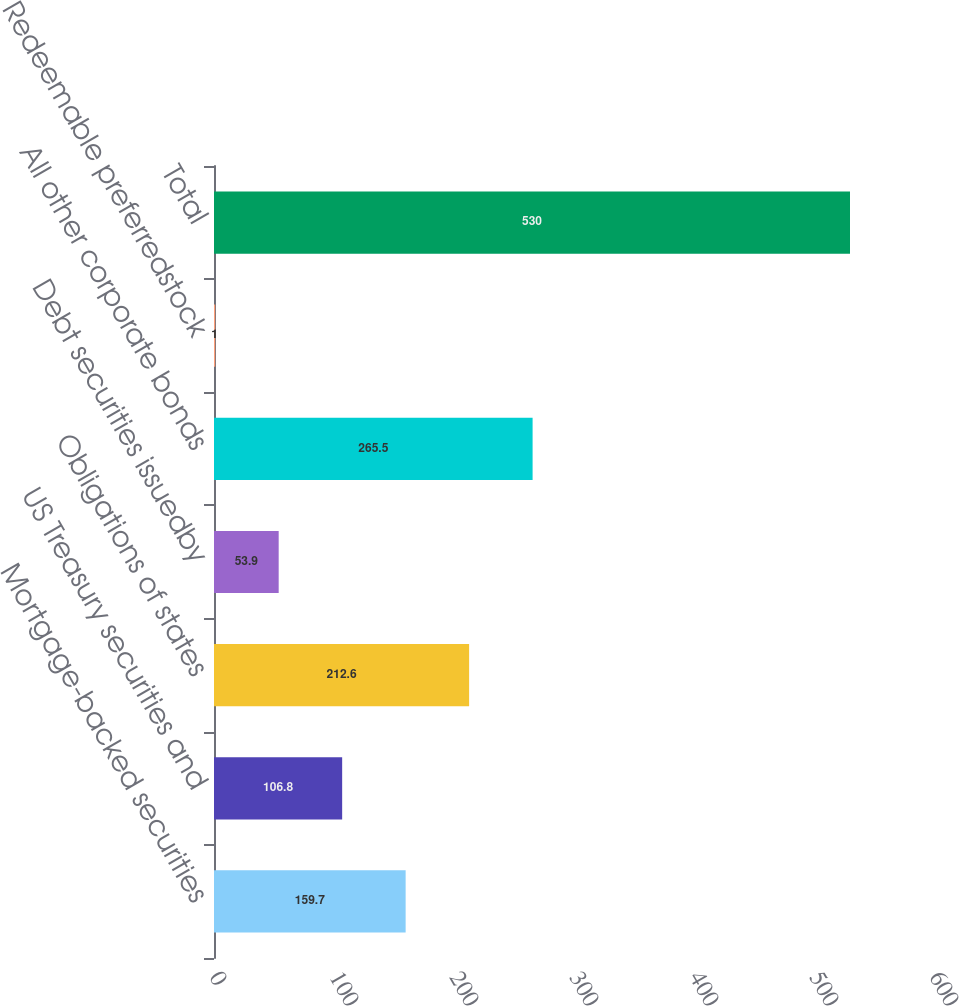<chart> <loc_0><loc_0><loc_500><loc_500><bar_chart><fcel>Mortgage-backed securities<fcel>US Treasury securities and<fcel>Obligations of states<fcel>Debt securities issuedby<fcel>All other corporate bonds<fcel>Redeemable preferredstock<fcel>Total<nl><fcel>159.7<fcel>106.8<fcel>212.6<fcel>53.9<fcel>265.5<fcel>1<fcel>530<nl></chart> 